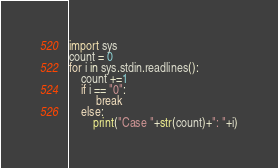<code> <loc_0><loc_0><loc_500><loc_500><_Python_>import sys
count = 0
for i in sys.stdin.readlines():
    count +=1
    if i == "0":
         break
    else:
        print("Case "+str(count)+": "+i)</code> 